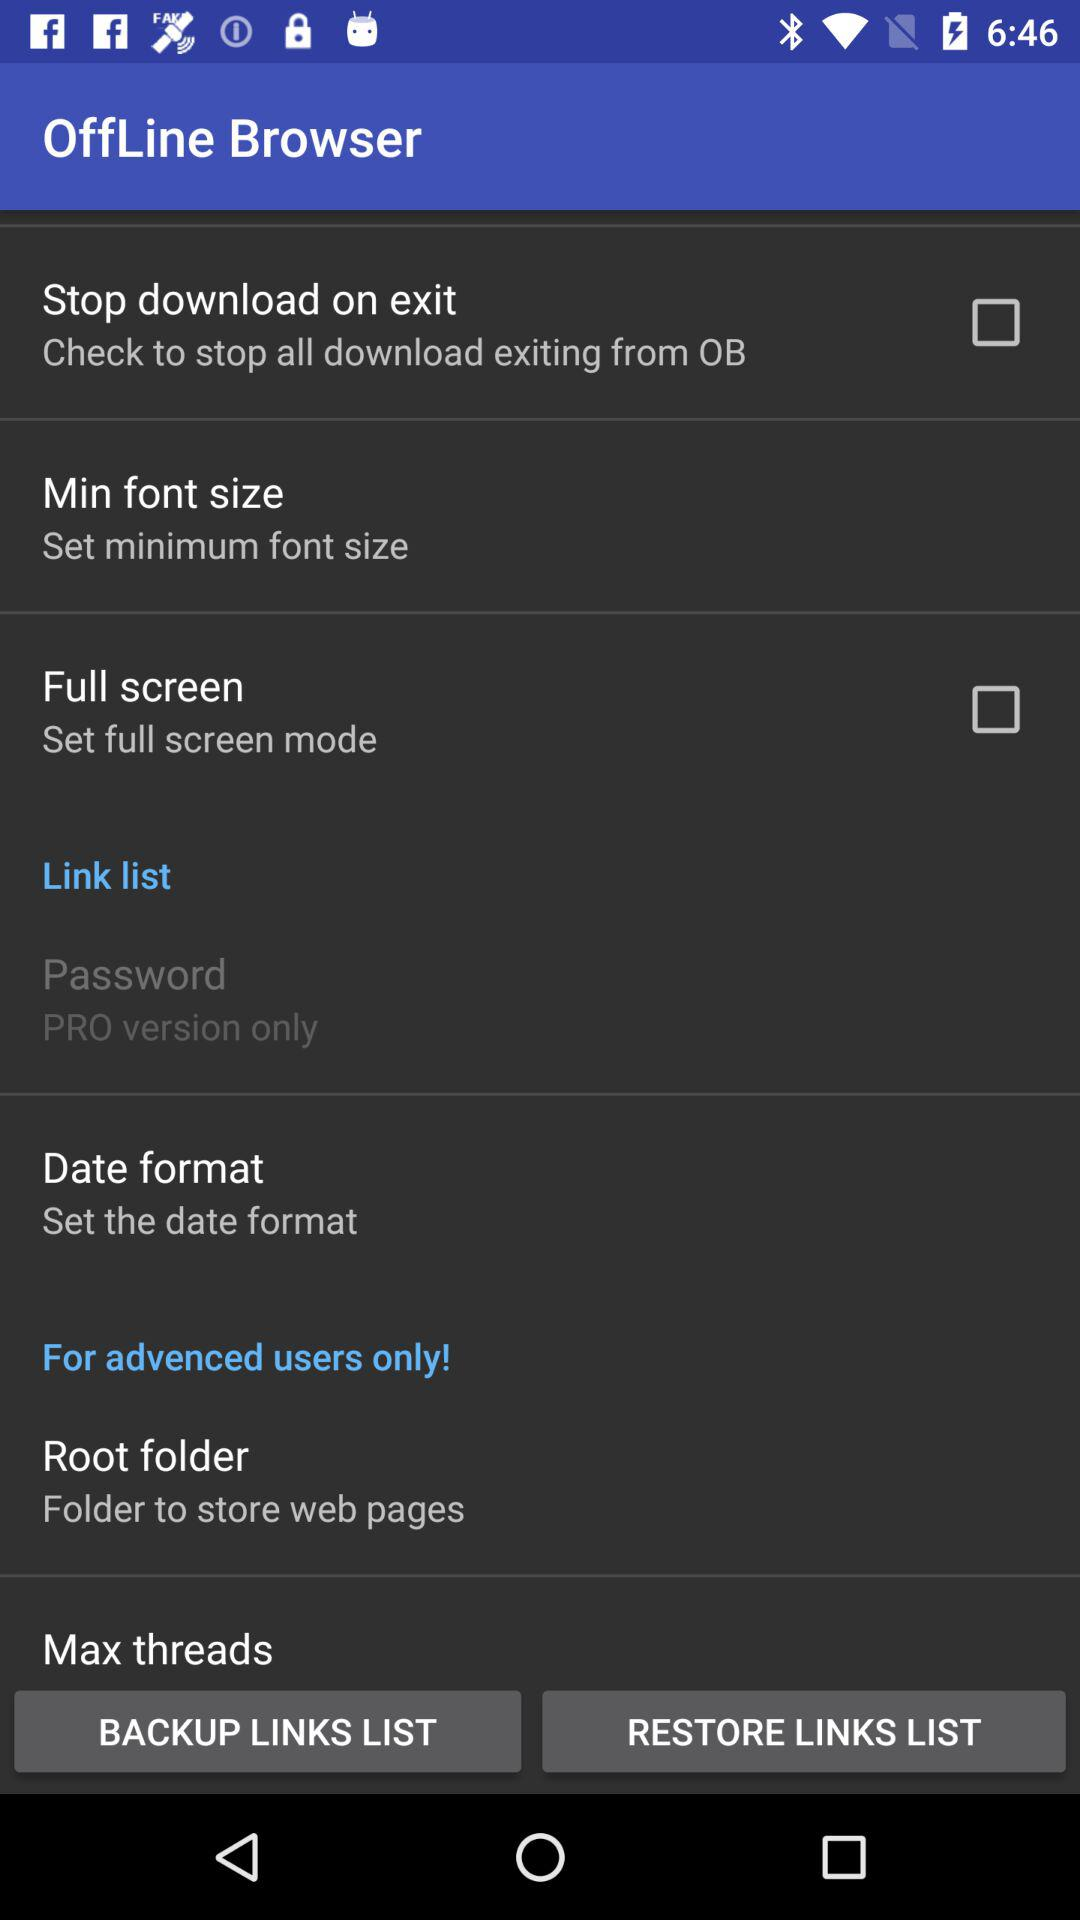What's the status of "Full screen"? The status is "off". 